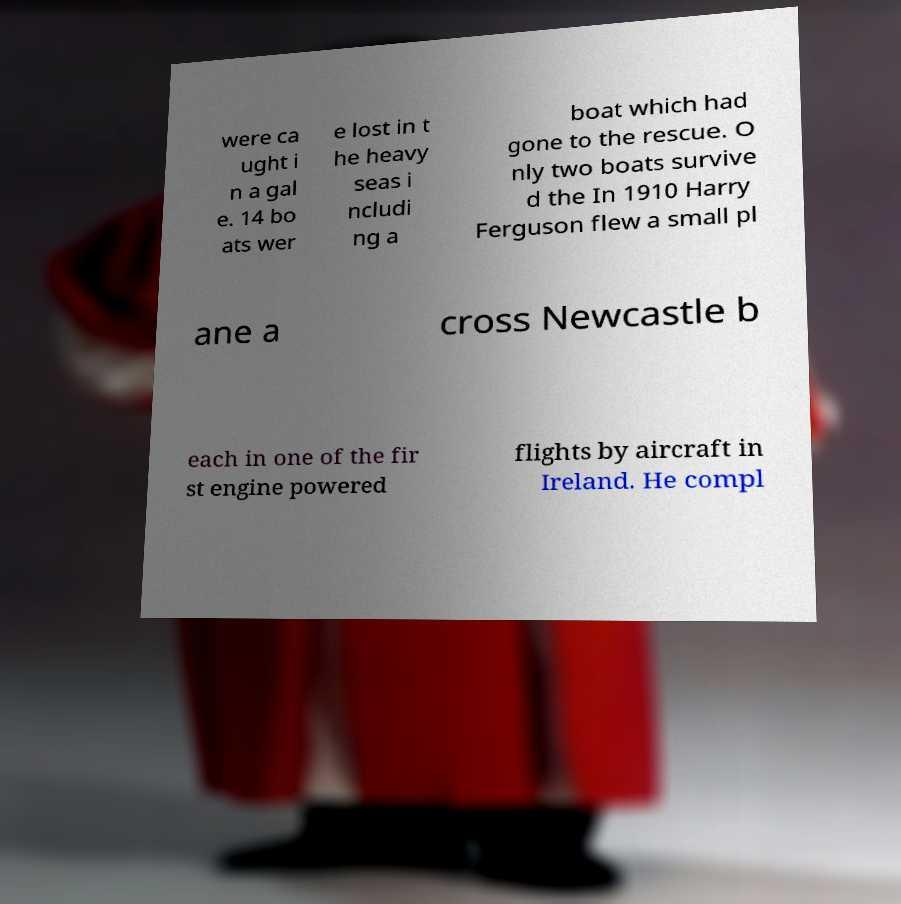Could you extract and type out the text from this image? were ca ught i n a gal e. 14 bo ats wer e lost in t he heavy seas i ncludi ng a boat which had gone to the rescue. O nly two boats survive d the In 1910 Harry Ferguson flew a small pl ane a cross Newcastle b each in one of the fir st engine powered flights by aircraft in Ireland. He compl 